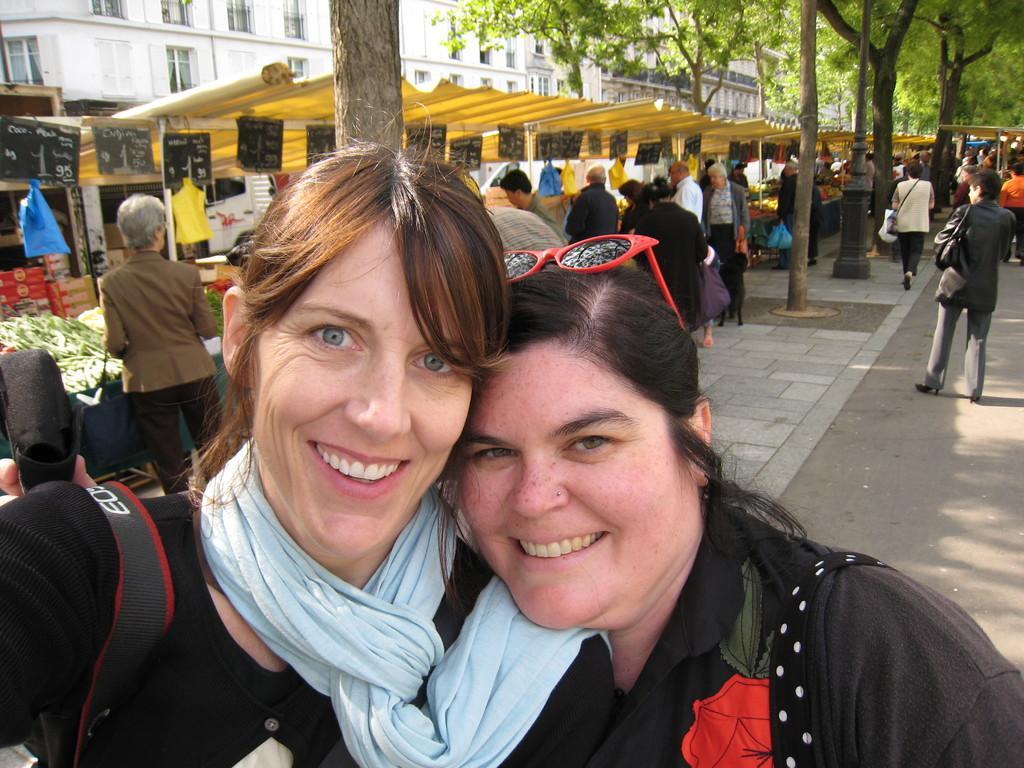How would you summarize this image in a sentence or two? In this picture I can see two persons smiling, there are boards, trees, stalls, there are group of people standing, and in the background these are looking like buildings. 